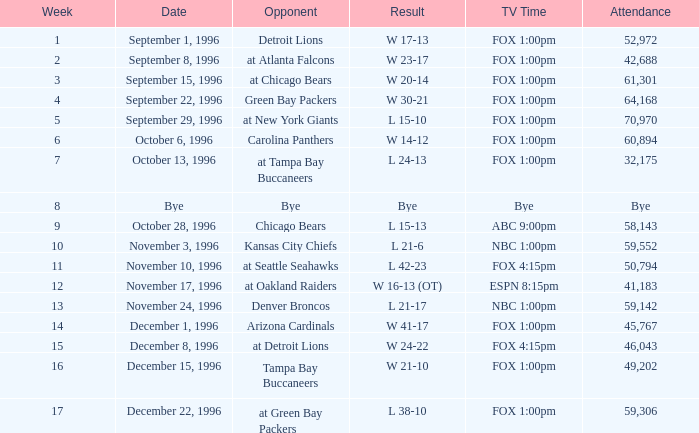Inform me of the least week for presence of 60,894 6.0. 